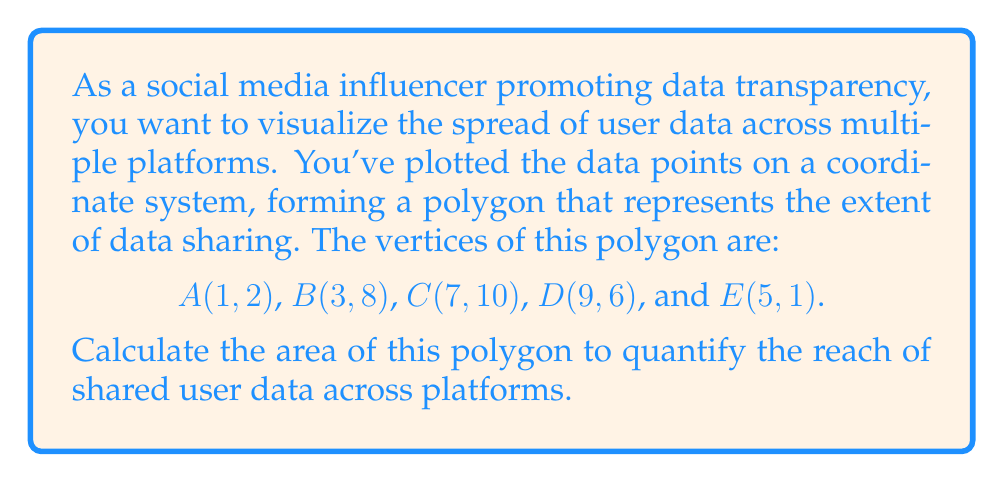What is the answer to this math problem? To find the area of an irregular polygon given its vertices, we can use the Shoelace formula (also known as the surveyor's formula). The steps are as follows:

1) First, let's arrange the vertices in order, including the first point at the end to close the polygon:
   (1, 2), (3, 8), (7, 10), (9, 6), (5, 1), (1, 2)

2) The Shoelace formula is:

   $$ A = \frac{1}{2}|\sum_{i=1}^{n} (x_i y_{i+1} - x_{i+1} y_i)| $$

   Where $(x_i, y_i)$ are the coordinates of the i-th vertex.

3) Let's calculate each term:
   $1(8) - 3(2) = 8 - 6 = 2$
   $3(10) - 7(8) = 30 - 56 = -26$
   $7(6) - 9(10) = 42 - 90 = -48$
   $9(1) - 5(6) = 9 - 30 = -21$
   $5(2) - 1(1) = 10 - 1 = 9$

4) Sum these terms:
   $2 + (-26) + (-48) + (-21) + 9 = -84$

5) Take the absolute value and divide by 2:
   $\frac{1}{2}|-84| = 42$

Therefore, the area of the polygon is 42 square units.

[asy]
unitsize(20);
draw((1,2)--(3,8)--(7,10)--(9,6)--(5,1)--cycle);
dot((1,2)); dot((3,8)); dot((7,10)); dot((9,6)); dot((5,1));
label("A(1,2)", (1,2), SW);
label("B(3,8)", (3,8), NW);
label("C(7,10)", (7,10), N);
label("D(9,6)", (9,6), E);
label("E(5,1)", (5,1), S);
[/asy]
Answer: The area of the polygon representing user data spread across multiple platforms is 42 square units. 